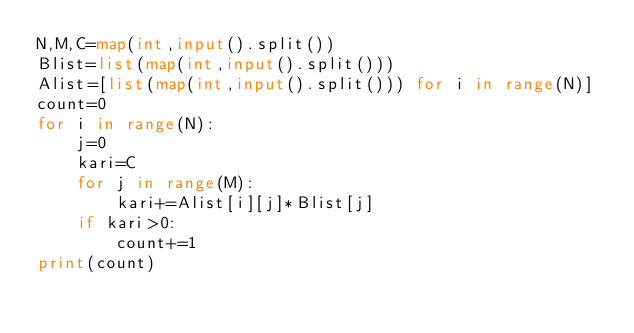Convert code to text. <code><loc_0><loc_0><loc_500><loc_500><_Python_>N,M,C=map(int,input().split())
Blist=list(map(int,input().split()))
Alist=[list(map(int,input().split())) for i in range(N)]
count=0
for i in range(N):
    j=0
    kari=C
    for j in range(M):
        kari+=Alist[i][j]*Blist[j]
    if kari>0:
        count+=1
print(count)</code> 